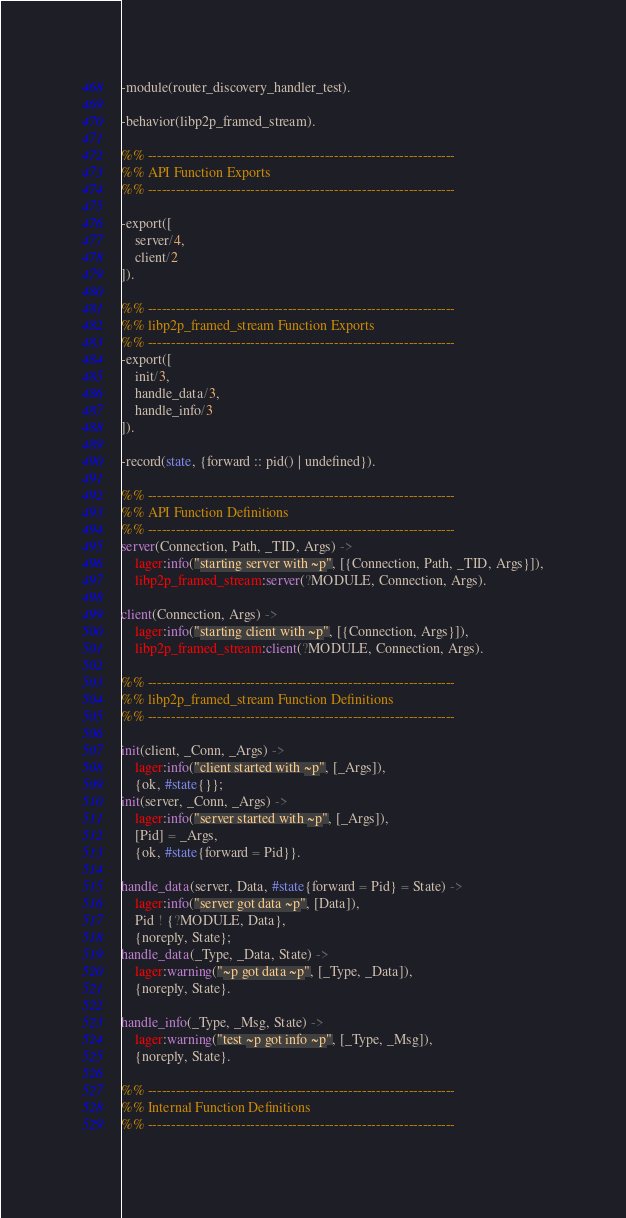Convert code to text. <code><loc_0><loc_0><loc_500><loc_500><_Erlang_>-module(router_discovery_handler_test).

-behavior(libp2p_framed_stream).

%% ------------------------------------------------------------------
%% API Function Exports
%% ------------------------------------------------------------------

-export([
    server/4,
    client/2
]).

%% ------------------------------------------------------------------
%% libp2p_framed_stream Function Exports
%% ------------------------------------------------------------------
-export([
    init/3,
    handle_data/3,
    handle_info/3
]).

-record(state, {forward :: pid() | undefined}).

%% ------------------------------------------------------------------
%% API Function Definitions
%% ------------------------------------------------------------------
server(Connection, Path, _TID, Args) ->
    lager:info("starting server with ~p", [{Connection, Path, _TID, Args}]),
    libp2p_framed_stream:server(?MODULE, Connection, Args).

client(Connection, Args) ->
    lager:info("starting client with ~p", [{Connection, Args}]),
    libp2p_framed_stream:client(?MODULE, Connection, Args).

%% ------------------------------------------------------------------
%% libp2p_framed_stream Function Definitions
%% ------------------------------------------------------------------

init(client, _Conn, _Args) ->
    lager:info("client started with ~p", [_Args]),
    {ok, #state{}};
init(server, _Conn, _Args) ->
    lager:info("server started with ~p", [_Args]),
    [Pid] = _Args,
    {ok, #state{forward = Pid}}.

handle_data(server, Data, #state{forward = Pid} = State) ->
    lager:info("server got data ~p", [Data]),
    Pid ! {?MODULE, Data},
    {noreply, State};
handle_data(_Type, _Data, State) ->
    lager:warning("~p got data ~p", [_Type, _Data]),
    {noreply, State}.

handle_info(_Type, _Msg, State) ->
    lager:warning("test ~p got info ~p", [_Type, _Msg]),
    {noreply, State}.

%% ------------------------------------------------------------------
%% Internal Function Definitions
%% ------------------------------------------------------------------
</code> 